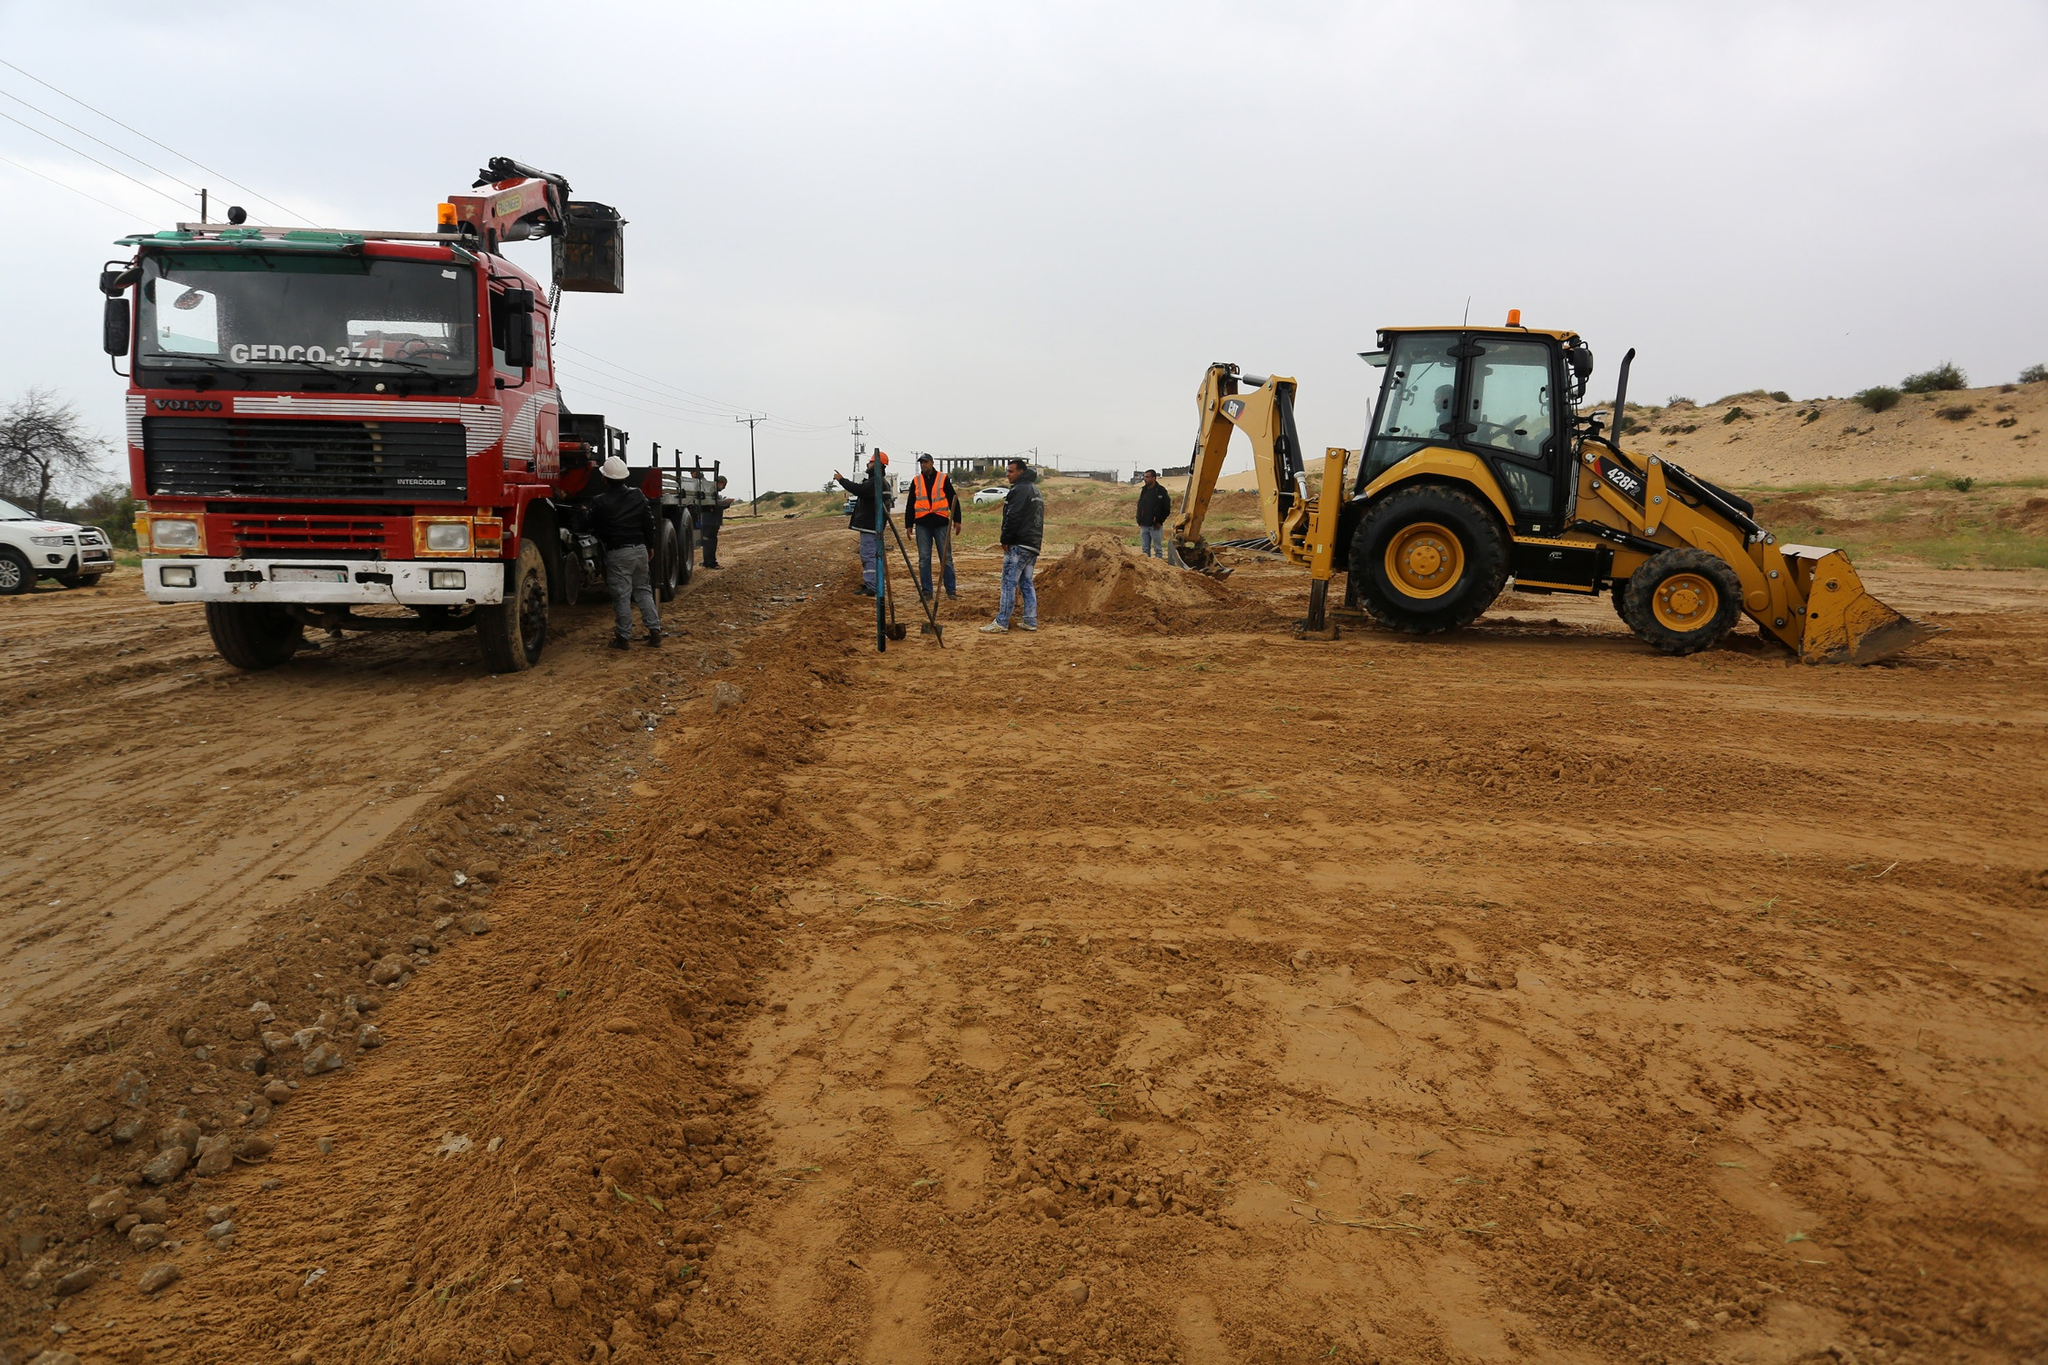If these machines could talk, what kind of conversation might they have? The red truck might say, 'Another day, another load to lift. How’s it going over on your side?' The bulldozer might respond, 'Pretty busy! Just got done leveling this section. Those workers sure are giving us a workout today!' The truck replies, 'sharegpt4v/same here! We’ve got to keep up; the project depends on us!' It’s a whimsical exchange reflecting their busy, pivotal roles on the site. Imagine the bulldozer and truck had personalities. Could you give them a name and a backstory? Sure! Let’s call the truck 'Red Rover.' He’s a seasoned veteran of the construction world, having worked on some of the biggest projects in the region. His sturdy frame and reliable crane have made him indispensable. The bulldozer, named 'Sunny,' is newer to the scene but eager to prove her worth. With her bright yellow paint and powerful shovel, Sunny has quickly become a favorite among the workers for her efficiency and capability. Together, they form an unstoppable duo, ready to tackle any challenge on the construction site. 